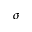Convert formula to latex. <formula><loc_0><loc_0><loc_500><loc_500>\sigma</formula> 